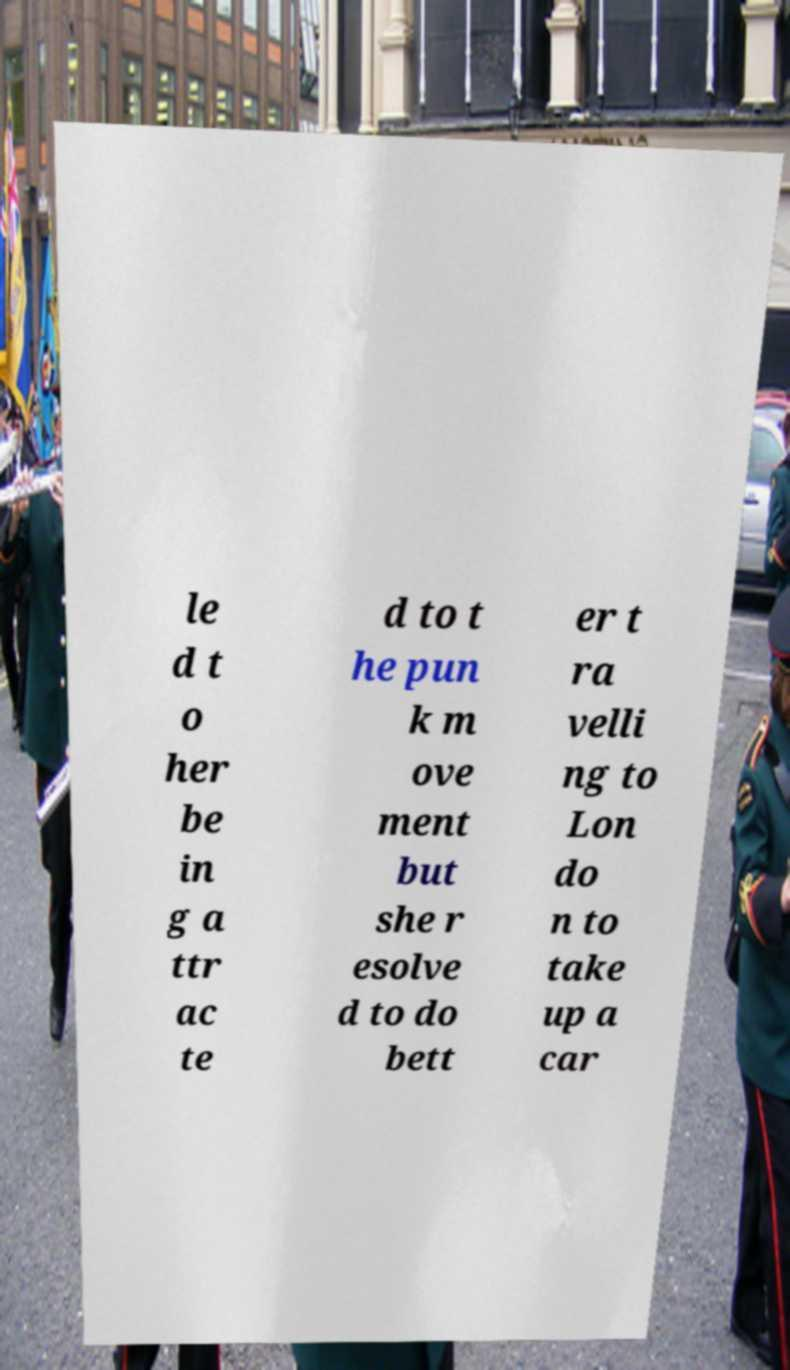Can you read and provide the text displayed in the image?This photo seems to have some interesting text. Can you extract and type it out for me? le d t o her be in g a ttr ac te d to t he pun k m ove ment but she r esolve d to do bett er t ra velli ng to Lon do n to take up a car 